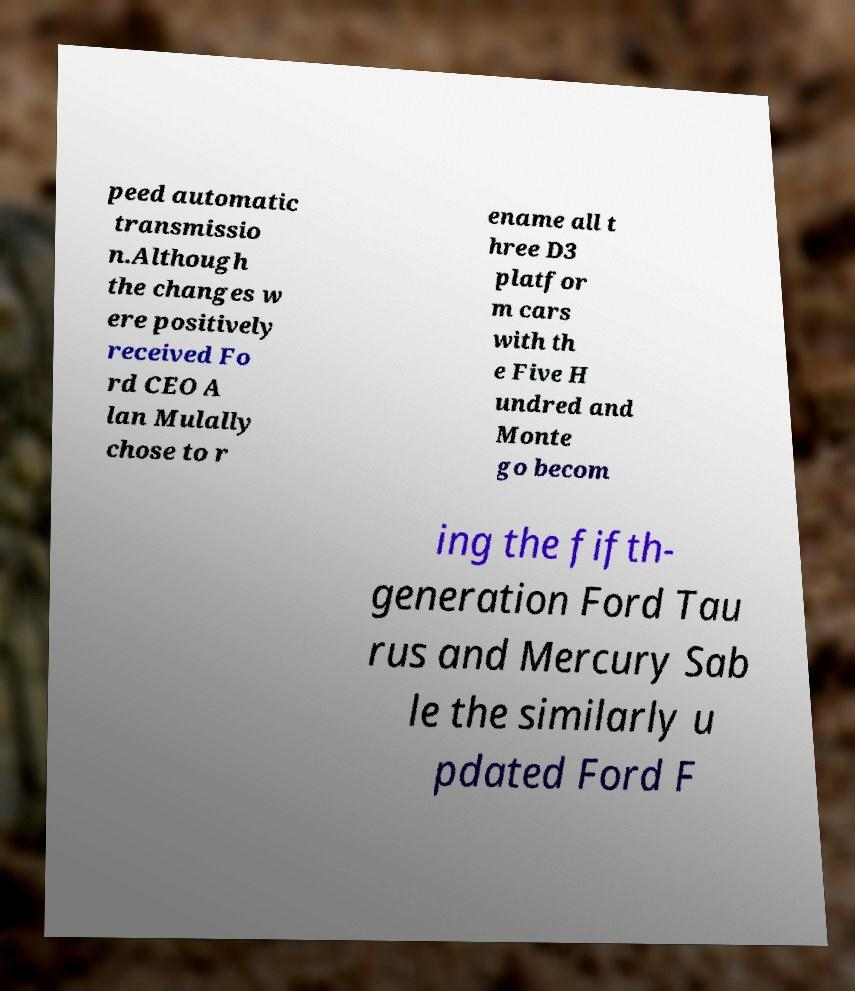I need the written content from this picture converted into text. Can you do that? peed automatic transmissio n.Although the changes w ere positively received Fo rd CEO A lan Mulally chose to r ename all t hree D3 platfor m cars with th e Five H undred and Monte go becom ing the fifth- generation Ford Tau rus and Mercury Sab le the similarly u pdated Ford F 